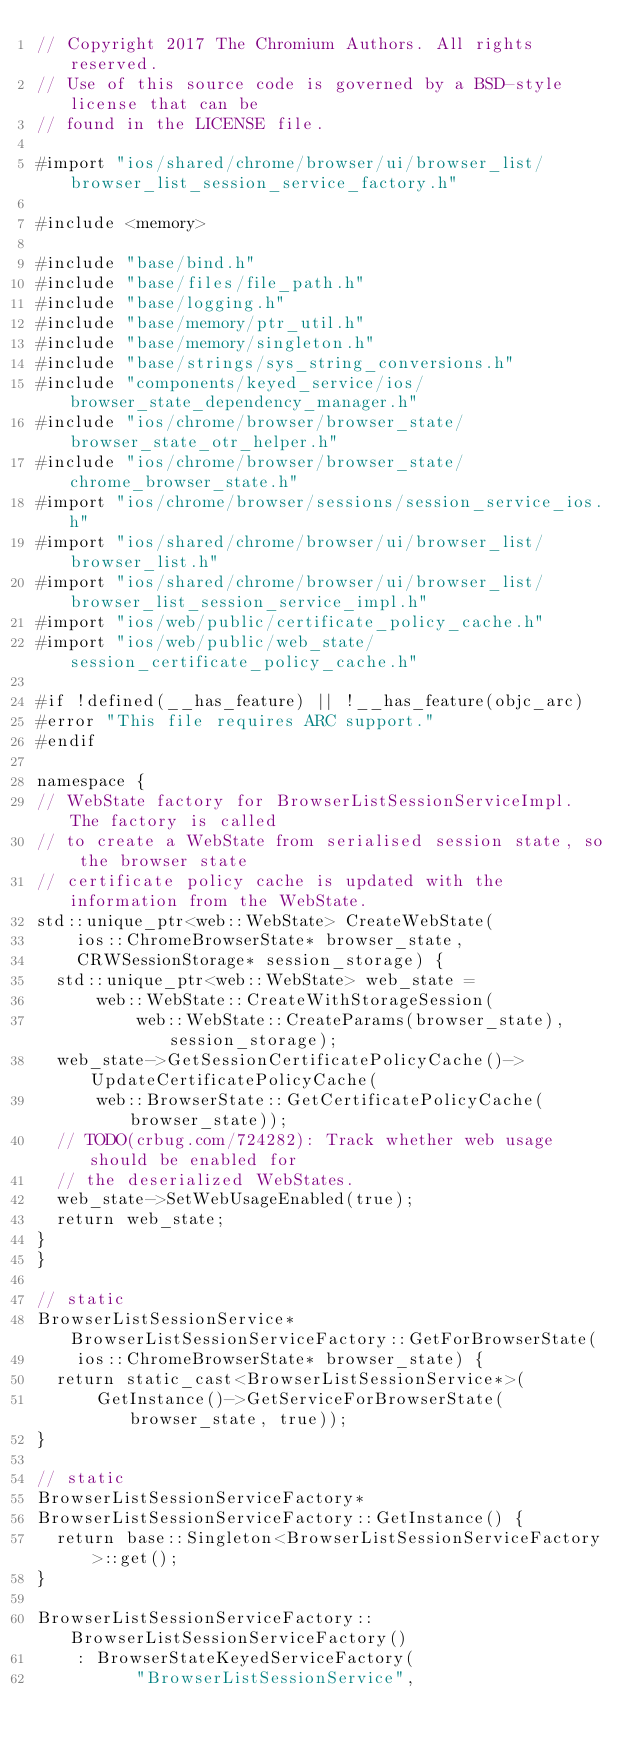Convert code to text. <code><loc_0><loc_0><loc_500><loc_500><_ObjectiveC_>// Copyright 2017 The Chromium Authors. All rights reserved.
// Use of this source code is governed by a BSD-style license that can be
// found in the LICENSE file.

#import "ios/shared/chrome/browser/ui/browser_list/browser_list_session_service_factory.h"

#include <memory>

#include "base/bind.h"
#include "base/files/file_path.h"
#include "base/logging.h"
#include "base/memory/ptr_util.h"
#include "base/memory/singleton.h"
#include "base/strings/sys_string_conversions.h"
#include "components/keyed_service/ios/browser_state_dependency_manager.h"
#include "ios/chrome/browser/browser_state/browser_state_otr_helper.h"
#include "ios/chrome/browser/browser_state/chrome_browser_state.h"
#import "ios/chrome/browser/sessions/session_service_ios.h"
#import "ios/shared/chrome/browser/ui/browser_list/browser_list.h"
#import "ios/shared/chrome/browser/ui/browser_list/browser_list_session_service_impl.h"
#import "ios/web/public/certificate_policy_cache.h"
#import "ios/web/public/web_state/session_certificate_policy_cache.h"

#if !defined(__has_feature) || !__has_feature(objc_arc)
#error "This file requires ARC support."
#endif

namespace {
// WebState factory for BrowserListSessionServiceImpl. The factory is called
// to create a WebState from serialised session state, so the browser state
// certificate policy cache is updated with the information from the WebState.
std::unique_ptr<web::WebState> CreateWebState(
    ios::ChromeBrowserState* browser_state,
    CRWSessionStorage* session_storage) {
  std::unique_ptr<web::WebState> web_state =
      web::WebState::CreateWithStorageSession(
          web::WebState::CreateParams(browser_state), session_storage);
  web_state->GetSessionCertificatePolicyCache()->UpdateCertificatePolicyCache(
      web::BrowserState::GetCertificatePolicyCache(browser_state));
  // TODO(crbug.com/724282): Track whether web usage should be enabled for
  // the deserialized WebStates.
  web_state->SetWebUsageEnabled(true);
  return web_state;
}
}

// static
BrowserListSessionService* BrowserListSessionServiceFactory::GetForBrowserState(
    ios::ChromeBrowserState* browser_state) {
  return static_cast<BrowserListSessionService*>(
      GetInstance()->GetServiceForBrowserState(browser_state, true));
}

// static
BrowserListSessionServiceFactory*
BrowserListSessionServiceFactory::GetInstance() {
  return base::Singleton<BrowserListSessionServiceFactory>::get();
}

BrowserListSessionServiceFactory::BrowserListSessionServiceFactory()
    : BrowserStateKeyedServiceFactory(
          "BrowserListSessionService",</code> 